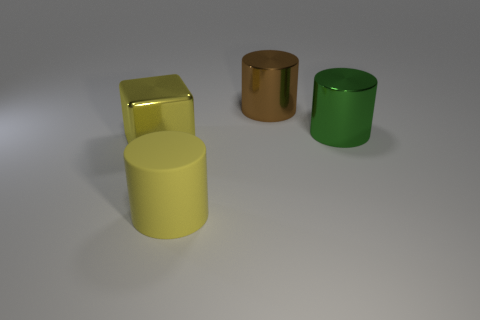Subtract all cyan cylinders. Subtract all yellow cubes. How many cylinders are left? 3 Add 3 brown metallic objects. How many objects exist? 7 Subtract all cylinders. How many objects are left? 1 Add 4 brown things. How many brown things exist? 5 Subtract 0 brown cubes. How many objects are left? 4 Subtract all large red metallic objects. Subtract all large brown metal cylinders. How many objects are left? 3 Add 2 yellow rubber things. How many yellow rubber things are left? 3 